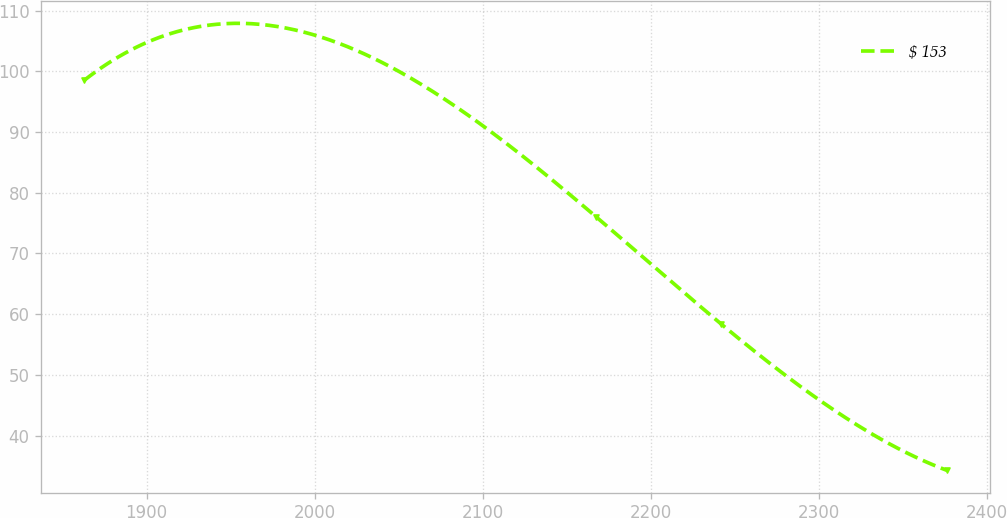Convert chart to OTSL. <chart><loc_0><loc_0><loc_500><loc_500><line_chart><ecel><fcel>$ 153<nl><fcel>1862.93<fcel>98.53<nl><fcel>2167.54<fcel>76.04<nl><fcel>2241.99<fcel>58.39<nl><fcel>2376.39<fcel>34.29<nl></chart> 